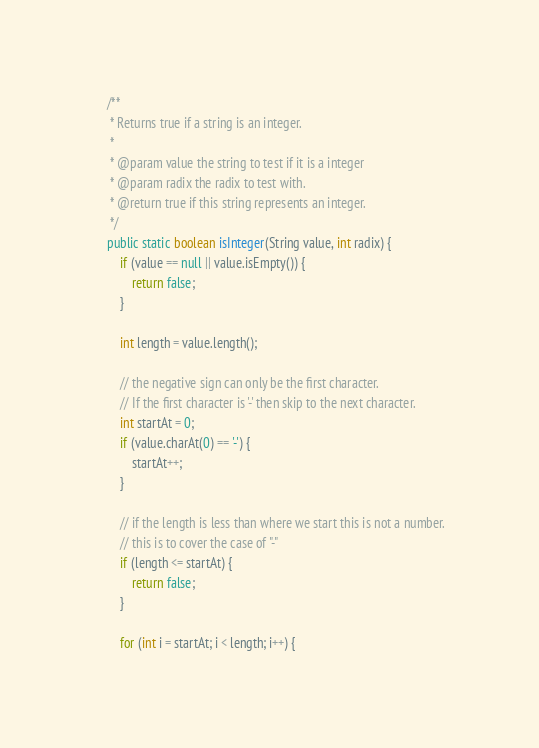Convert code to text. <code><loc_0><loc_0><loc_500><loc_500><_Java_>
    /**
     * Returns true if a string is an integer.
     *
     * @param value the string to test if it is a integer
     * @param radix the radix to test with.
     * @return true if this string represents an integer.
     */
    public static boolean isInteger(String value, int radix) {
        if (value == null || value.isEmpty()) {
            return false;
        }

        int length = value.length();

        // the negative sign can only be the first character.
        // If the first character is '-' then skip to the next character.
        int startAt = 0;
        if (value.charAt(0) == '-') {
            startAt++;
        }

        // if the length is less than where we start this is not a number.
        // this is to cover the case of "-"
        if (length <= startAt) {
            return false;
        }

        for (int i = startAt; i < length; i++) {</code> 